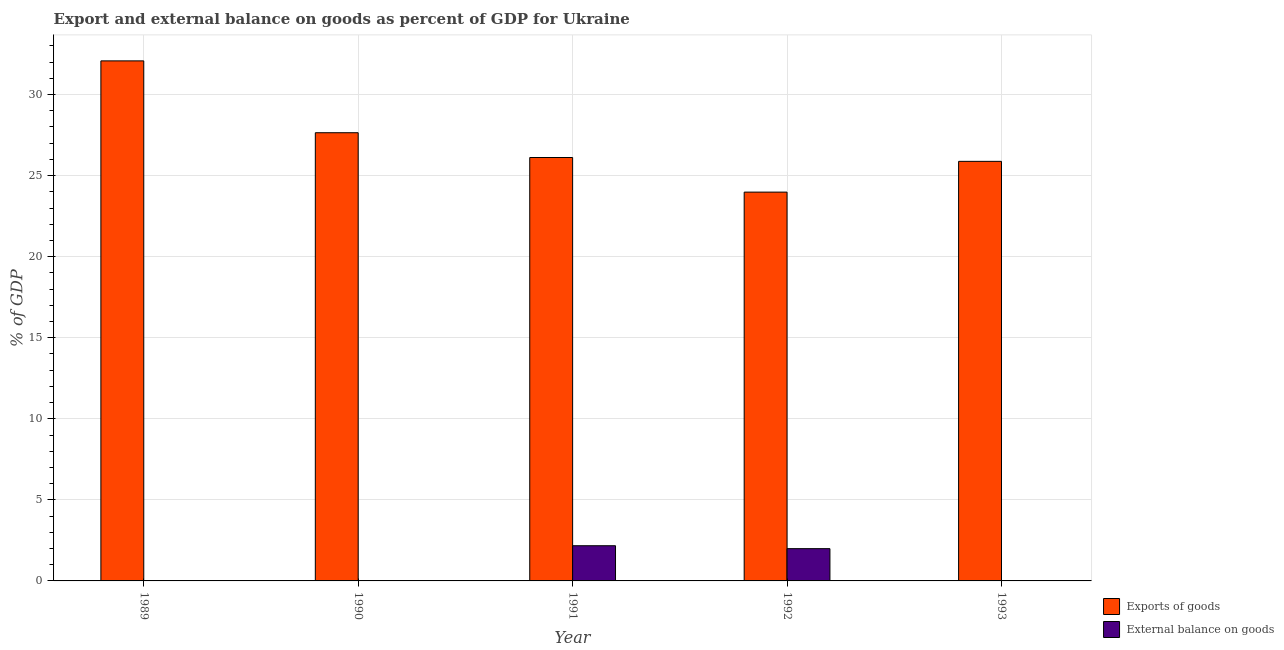Are the number of bars on each tick of the X-axis equal?
Ensure brevity in your answer.  No. How many bars are there on the 3rd tick from the right?
Provide a succinct answer. 2. What is the label of the 2nd group of bars from the left?
Offer a terse response. 1990. What is the external balance on goods as percentage of gdp in 1990?
Provide a short and direct response. 0. Across all years, what is the maximum external balance on goods as percentage of gdp?
Keep it short and to the point. 2.17. Across all years, what is the minimum external balance on goods as percentage of gdp?
Your response must be concise. 0. In which year was the export of goods as percentage of gdp maximum?
Ensure brevity in your answer.  1989. What is the total external balance on goods as percentage of gdp in the graph?
Keep it short and to the point. 4.16. What is the difference between the export of goods as percentage of gdp in 1991 and that in 1993?
Ensure brevity in your answer.  0.24. What is the difference between the export of goods as percentage of gdp in 1992 and the external balance on goods as percentage of gdp in 1993?
Keep it short and to the point. -1.9. What is the average export of goods as percentage of gdp per year?
Keep it short and to the point. 27.14. What is the ratio of the export of goods as percentage of gdp in 1989 to that in 1990?
Ensure brevity in your answer.  1.16. Is the export of goods as percentage of gdp in 1991 less than that in 1993?
Your answer should be very brief. No. What is the difference between the highest and the second highest export of goods as percentage of gdp?
Provide a succinct answer. 4.43. What is the difference between the highest and the lowest export of goods as percentage of gdp?
Offer a terse response. 8.09. In how many years, is the external balance on goods as percentage of gdp greater than the average external balance on goods as percentage of gdp taken over all years?
Make the answer very short. 2. Is the sum of the export of goods as percentage of gdp in 1990 and 1991 greater than the maximum external balance on goods as percentage of gdp across all years?
Offer a very short reply. Yes. How many bars are there?
Provide a succinct answer. 7. How many years are there in the graph?
Offer a very short reply. 5. Does the graph contain any zero values?
Make the answer very short. Yes. How are the legend labels stacked?
Ensure brevity in your answer.  Vertical. What is the title of the graph?
Give a very brief answer. Export and external balance on goods as percent of GDP for Ukraine. What is the label or title of the X-axis?
Offer a terse response. Year. What is the label or title of the Y-axis?
Ensure brevity in your answer.  % of GDP. What is the % of GDP in Exports of goods in 1989?
Make the answer very short. 32.08. What is the % of GDP of External balance on goods in 1989?
Make the answer very short. 0. What is the % of GDP in Exports of goods in 1990?
Provide a short and direct response. 27.64. What is the % of GDP in External balance on goods in 1990?
Provide a succinct answer. 0. What is the % of GDP in Exports of goods in 1991?
Provide a short and direct response. 26.12. What is the % of GDP in External balance on goods in 1991?
Ensure brevity in your answer.  2.17. What is the % of GDP in Exports of goods in 1992?
Provide a succinct answer. 23.98. What is the % of GDP of External balance on goods in 1992?
Provide a short and direct response. 1.99. What is the % of GDP in Exports of goods in 1993?
Your response must be concise. 25.88. Across all years, what is the maximum % of GDP in Exports of goods?
Keep it short and to the point. 32.08. Across all years, what is the maximum % of GDP in External balance on goods?
Your response must be concise. 2.17. Across all years, what is the minimum % of GDP in Exports of goods?
Provide a short and direct response. 23.98. Across all years, what is the minimum % of GDP in External balance on goods?
Provide a succinct answer. 0. What is the total % of GDP of Exports of goods in the graph?
Give a very brief answer. 135.69. What is the total % of GDP in External balance on goods in the graph?
Give a very brief answer. 4.16. What is the difference between the % of GDP in Exports of goods in 1989 and that in 1990?
Provide a succinct answer. 4.43. What is the difference between the % of GDP in Exports of goods in 1989 and that in 1991?
Your response must be concise. 5.96. What is the difference between the % of GDP in Exports of goods in 1989 and that in 1992?
Keep it short and to the point. 8.09. What is the difference between the % of GDP in Exports of goods in 1989 and that in 1993?
Your response must be concise. 6.2. What is the difference between the % of GDP in Exports of goods in 1990 and that in 1991?
Provide a succinct answer. 1.53. What is the difference between the % of GDP in Exports of goods in 1990 and that in 1992?
Ensure brevity in your answer.  3.66. What is the difference between the % of GDP of Exports of goods in 1990 and that in 1993?
Ensure brevity in your answer.  1.77. What is the difference between the % of GDP in Exports of goods in 1991 and that in 1992?
Provide a short and direct response. 2.13. What is the difference between the % of GDP of External balance on goods in 1991 and that in 1992?
Your answer should be compact. 0.18. What is the difference between the % of GDP in Exports of goods in 1991 and that in 1993?
Ensure brevity in your answer.  0.24. What is the difference between the % of GDP in Exports of goods in 1992 and that in 1993?
Offer a very short reply. -1.9. What is the difference between the % of GDP of Exports of goods in 1989 and the % of GDP of External balance on goods in 1991?
Offer a very short reply. 29.9. What is the difference between the % of GDP of Exports of goods in 1989 and the % of GDP of External balance on goods in 1992?
Provide a succinct answer. 30.08. What is the difference between the % of GDP of Exports of goods in 1990 and the % of GDP of External balance on goods in 1991?
Provide a short and direct response. 25.47. What is the difference between the % of GDP of Exports of goods in 1990 and the % of GDP of External balance on goods in 1992?
Offer a terse response. 25.65. What is the difference between the % of GDP in Exports of goods in 1991 and the % of GDP in External balance on goods in 1992?
Ensure brevity in your answer.  24.12. What is the average % of GDP of Exports of goods per year?
Make the answer very short. 27.14. What is the average % of GDP in External balance on goods per year?
Offer a terse response. 0.83. In the year 1991, what is the difference between the % of GDP in Exports of goods and % of GDP in External balance on goods?
Ensure brevity in your answer.  23.94. In the year 1992, what is the difference between the % of GDP of Exports of goods and % of GDP of External balance on goods?
Provide a short and direct response. 21.99. What is the ratio of the % of GDP of Exports of goods in 1989 to that in 1990?
Ensure brevity in your answer.  1.16. What is the ratio of the % of GDP in Exports of goods in 1989 to that in 1991?
Give a very brief answer. 1.23. What is the ratio of the % of GDP in Exports of goods in 1989 to that in 1992?
Keep it short and to the point. 1.34. What is the ratio of the % of GDP of Exports of goods in 1989 to that in 1993?
Make the answer very short. 1.24. What is the ratio of the % of GDP of Exports of goods in 1990 to that in 1991?
Give a very brief answer. 1.06. What is the ratio of the % of GDP of Exports of goods in 1990 to that in 1992?
Provide a succinct answer. 1.15. What is the ratio of the % of GDP in Exports of goods in 1990 to that in 1993?
Make the answer very short. 1.07. What is the ratio of the % of GDP in Exports of goods in 1991 to that in 1992?
Make the answer very short. 1.09. What is the ratio of the % of GDP of External balance on goods in 1991 to that in 1992?
Give a very brief answer. 1.09. What is the ratio of the % of GDP in Exports of goods in 1991 to that in 1993?
Provide a succinct answer. 1.01. What is the ratio of the % of GDP of Exports of goods in 1992 to that in 1993?
Keep it short and to the point. 0.93. What is the difference between the highest and the second highest % of GDP of Exports of goods?
Offer a terse response. 4.43. What is the difference between the highest and the lowest % of GDP of Exports of goods?
Provide a succinct answer. 8.09. What is the difference between the highest and the lowest % of GDP of External balance on goods?
Ensure brevity in your answer.  2.17. 